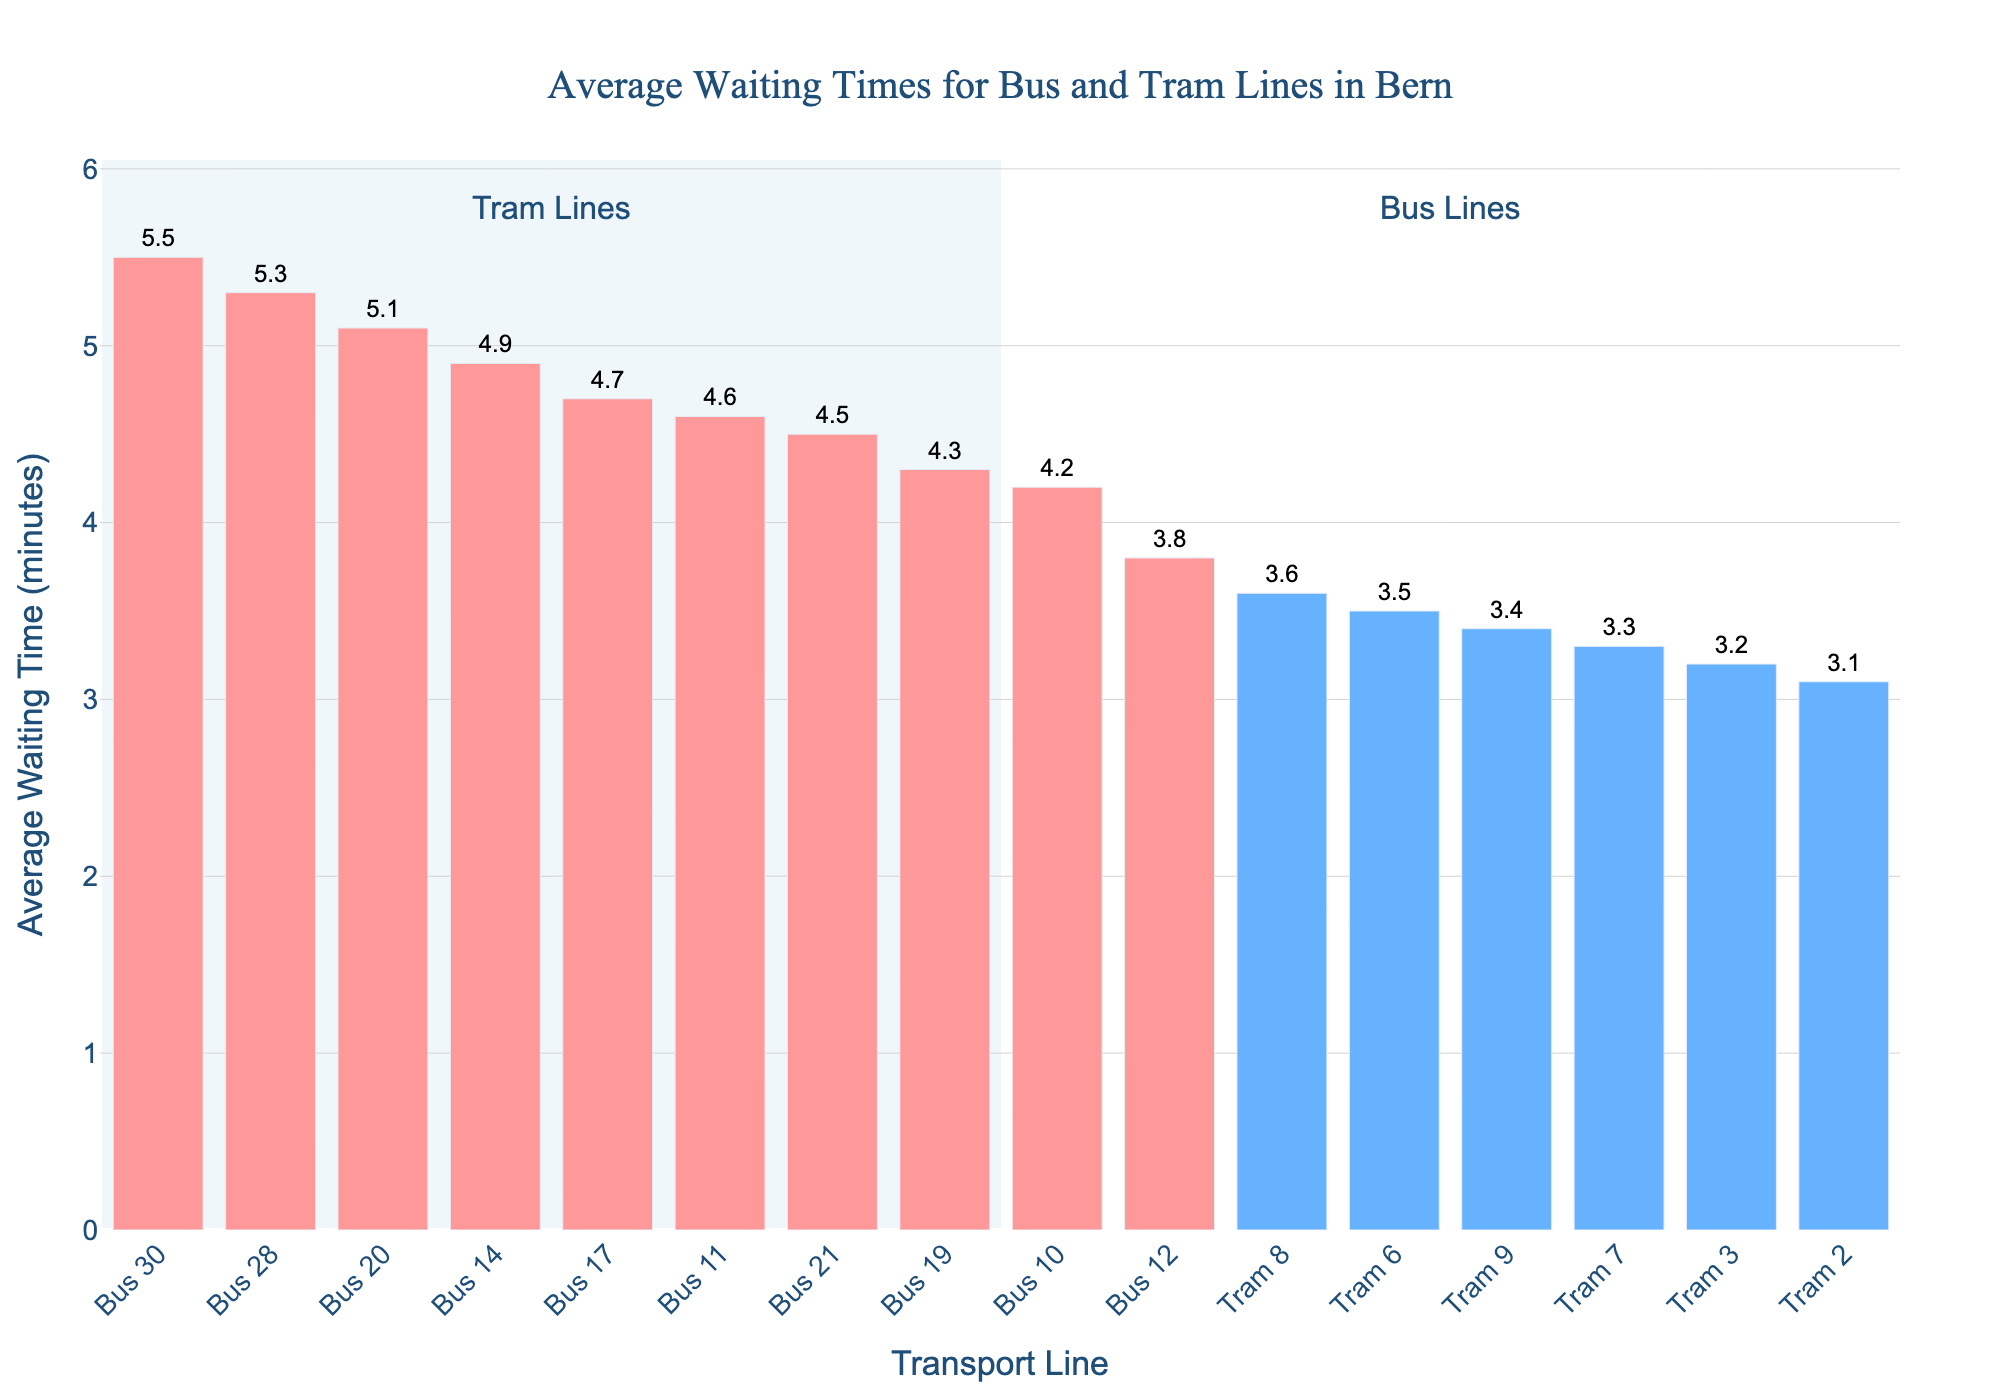What is the average waiting time for Bus 30? Locate the bar representing Bus 30, and the associated value text indicates the waiting time for Bus 30.
Answer: 5.5 minutes Which transport line has the shortest average waiting time? By comparing the height of the bars, identify the shortest bar. The label of this bar represents the transport line with the shortest waiting time, which is Tram 2.
Answer: Tram 2 How much longer is the waiting time for Bus 30 compared to Tram 2? Subtract the wait time of Tram 2 from Bus 30: 5.5 minutes (Bus 30) - 3.1 minutes (Tram 2) = 2.4 minutes
Answer: 2.4 minutes Are the tram lines' average waiting times generally shorter or longer than bus lines' waiting times? Observing both tram and bus sections, it’s visible that the tram lines generally have shorter bars, indicating shorter waiting times compared to bus lines.
Answer: Shorter What is the combined average waiting time for Bus 28 and Tram 3? Add the waiting times of Bus 28 (5.3 minutes) and Tram 3 (3.2 minutes): 5.3 + 3.2 = 8.5 minutes.
Answer: 8.5 minutes Which bus line has the highest waiting time, and what is it? Identify the tallest bar within the bus lines section, which represents Bus 30, with a waiting time indicated.
Answer: Bus 30, 5.5 minutes How many tram lines have a waiting time under 3.5 minutes? Count the bars within the tram section with waiting times below 3.5 minutes: Tram 2, Tram 3, and Tram 7.
Answer: 3 tram lines Which has a greater range of waiting times, bus lines or tram lines? Determine the range for each: Bus lines: 5.5 minutes (Bus 30) - 3.8 minutes (Bus 12) = 1.7 minutes. Tram lines: 3.6 minutes (Tram 8) - 3.1 minutes (Tram 2) = 0.5 minutes. Comparing the two, bus lines have a greater range.
Answer: Bus lines What is the median waiting time for all tram lines? List the tram waiting times: 3.1, 3.2, 3.3, 3.4, 3.5, 3.6. Since there’s an even number, the median is the average of the two middle values: (3.3 + 3.4) / 2 = 3.35 minutes.
Answer: 3.35 minutes 